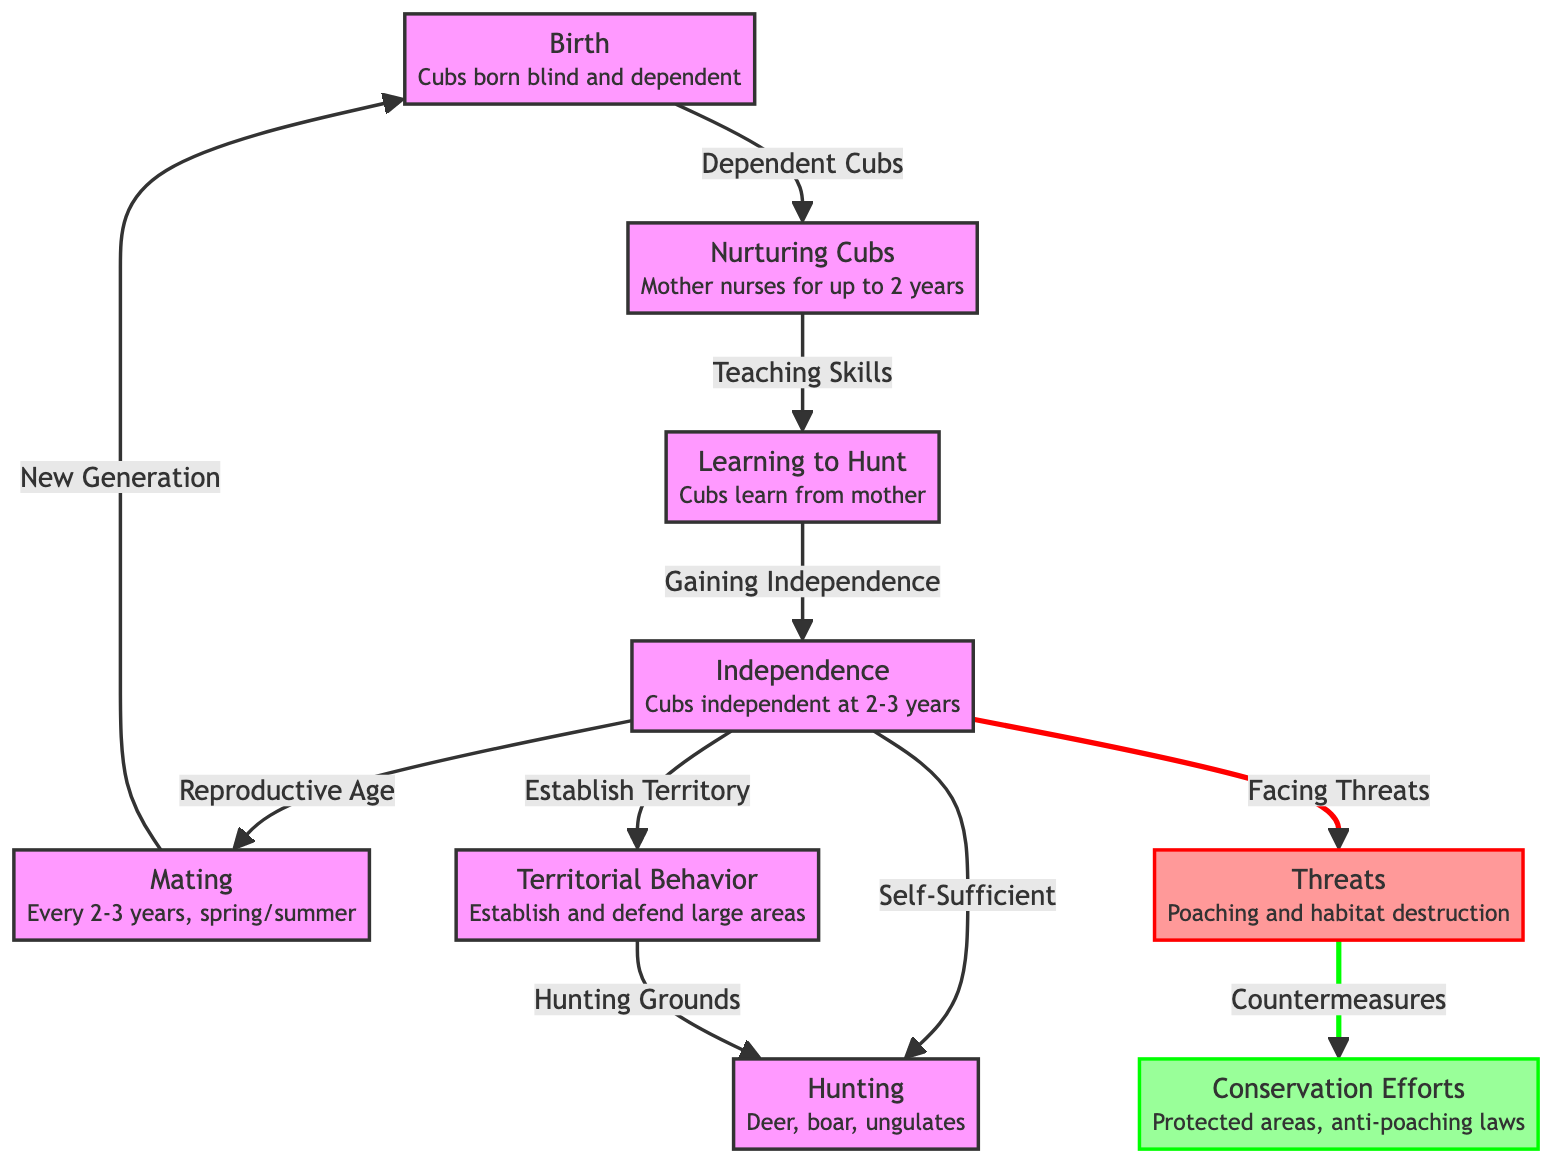What is the first event in the lifecycle of the Siberian tiger? The diagram starts with the "Birth" node, indicating that the lifecycle begins with the cubs being born.
Answer: Birth At what age do cubs become independent? The "Independence" node specifies that cubs become independent at 2-3 years old.
Answer: 2-3 years What behavior do cubs learn from their mother? The "Learning to Hunt" node indicates that cubs learn hunting skills from their mother.
Answer: Hunting How often do Siberian tigers mate? The "Mating" node states that Siberian tigers mate every 2-3 years.
Answer: Every 2-3 years Which two major threats are specified in the diagram? The "Threats" node lists "Poaching and habitat destruction," indicating these are the major threats faced.
Answer: Poaching and habitat destruction What do independence, territory, and hunting have in common? All three nodes (Independence, Territory, Hunting) stem from the independence phase of the life process, showing a connection to their adult behavior after leaving their mother.
Answer: They are outcomes of independence What leads to the establishment of hunting grounds? The "Territory" node leads to the "Hunting" node, indicating that establishing a territory is essential for securing hunting grounds.
Answer: Territory What type of conservation efforts are mentioned? The "Conservation Efforts" node specifies measures like "Protected areas" and "anti-poaching laws."
Answer: Protected areas, anti-poaching laws Which two aspects of the tiger’s life are most affected by threats? The "Facing Threats" node links to "Mating" and "Independence," indicating these aspects are critically threatened.
Answer: Mating and Independence What symbolizes the flow of the Siberian tiger's lifecycle? The arrows in the flowchart indicate the progression from one life stage to the next, symbolizing the lifecycle.
Answer: Arrows 